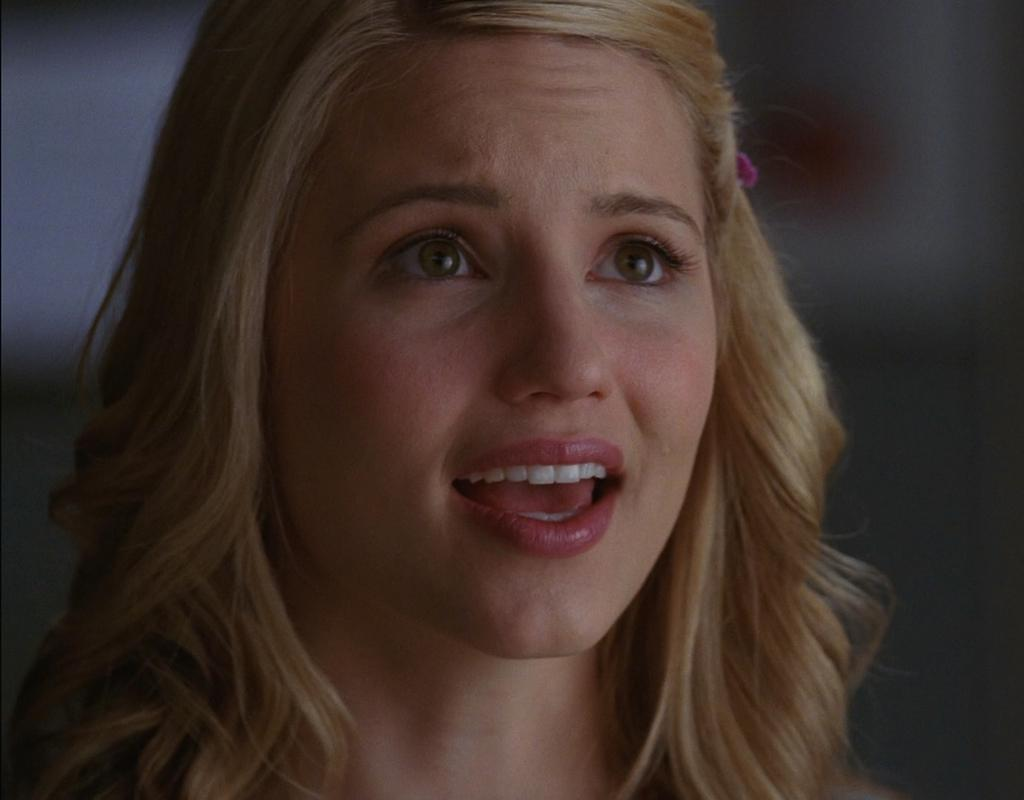What is the main subject of the image? The main subject of the image is a girl's face. What direction is the girl's face facing in the image? The direction the girl's face is facing cannot be determined from the image, as only her face is visible. How many rings is the girl wearing in the image? There is no information about rings or any other accessories in the image, as it only shows the girl's face. 